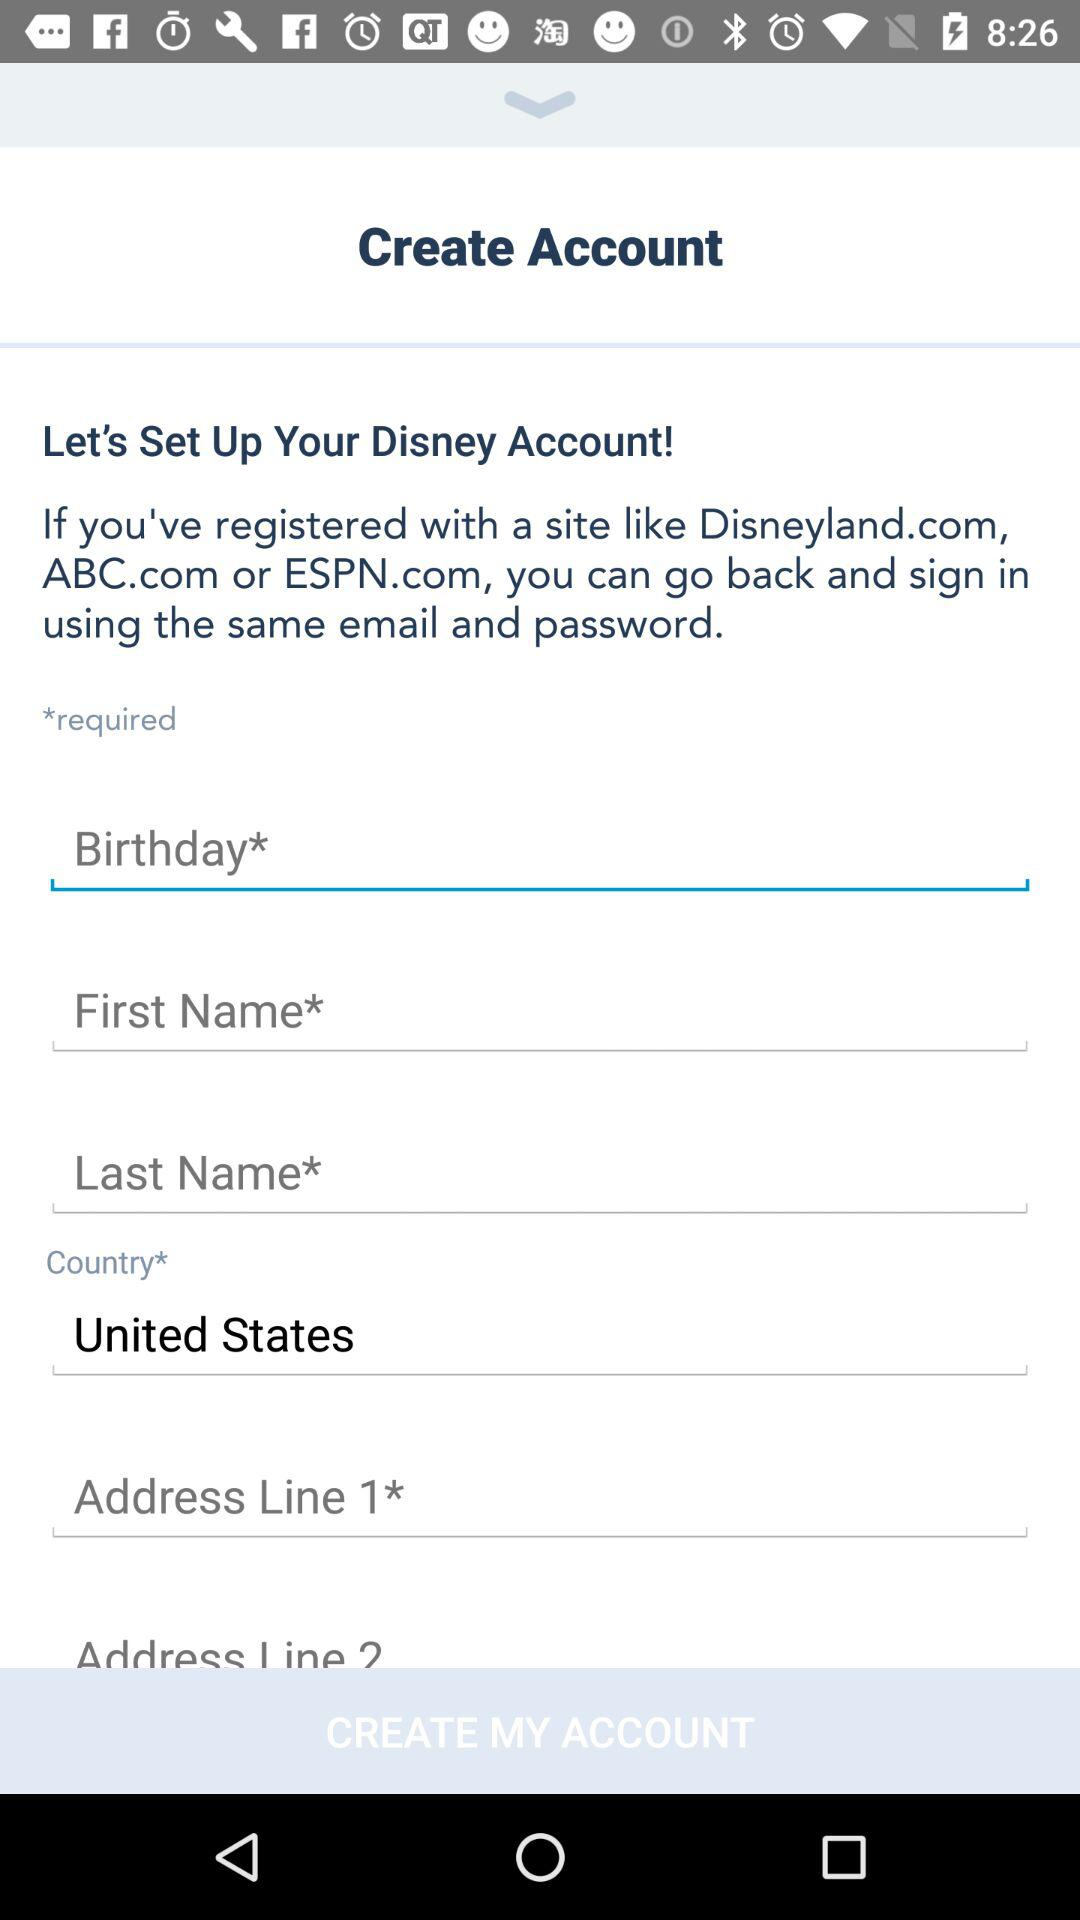How many text inputs require a value?
Answer the question using a single word or phrase. 5 